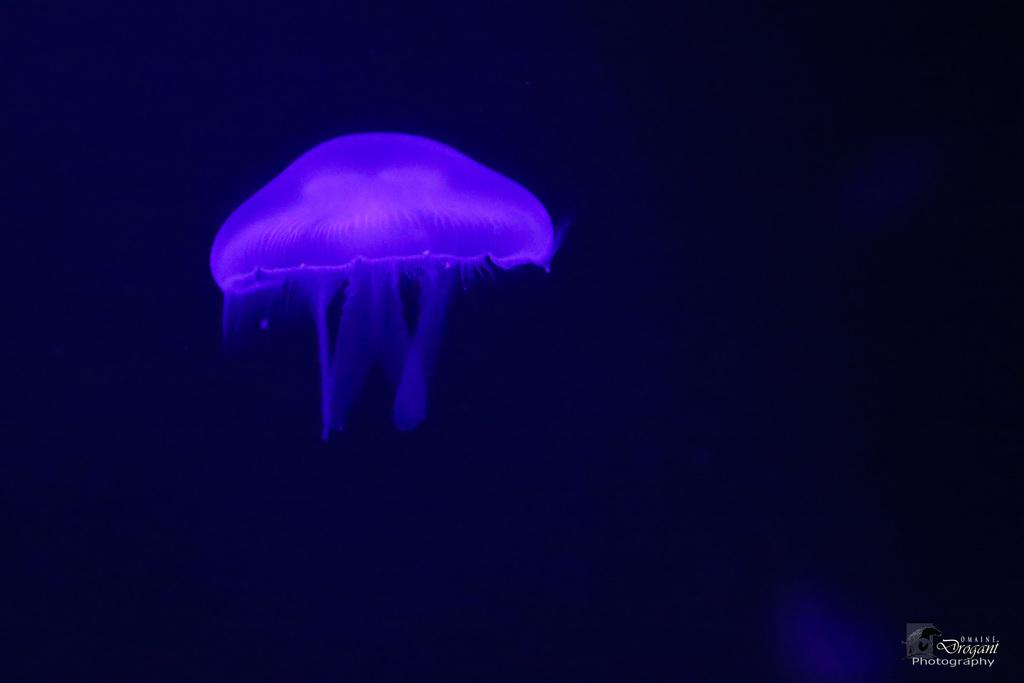What is the main subject of the image? There is a jellyfish in the image. What color is the jellyfish? The jellyfish is blue in color. What color is the background of the image? The background of the image is black. Is there any text in the image? Yes, there is some text in the bottom right corner of the image. What type of stocking is the jellyfish wearing on its tentacles in the image? There is no stocking present in the image, as it features a jellyfish with tentacles. How many teeth can be seen on the jellyfish in the image? Jellyfish do not have teeth, so there are no teeth visible in the image. 